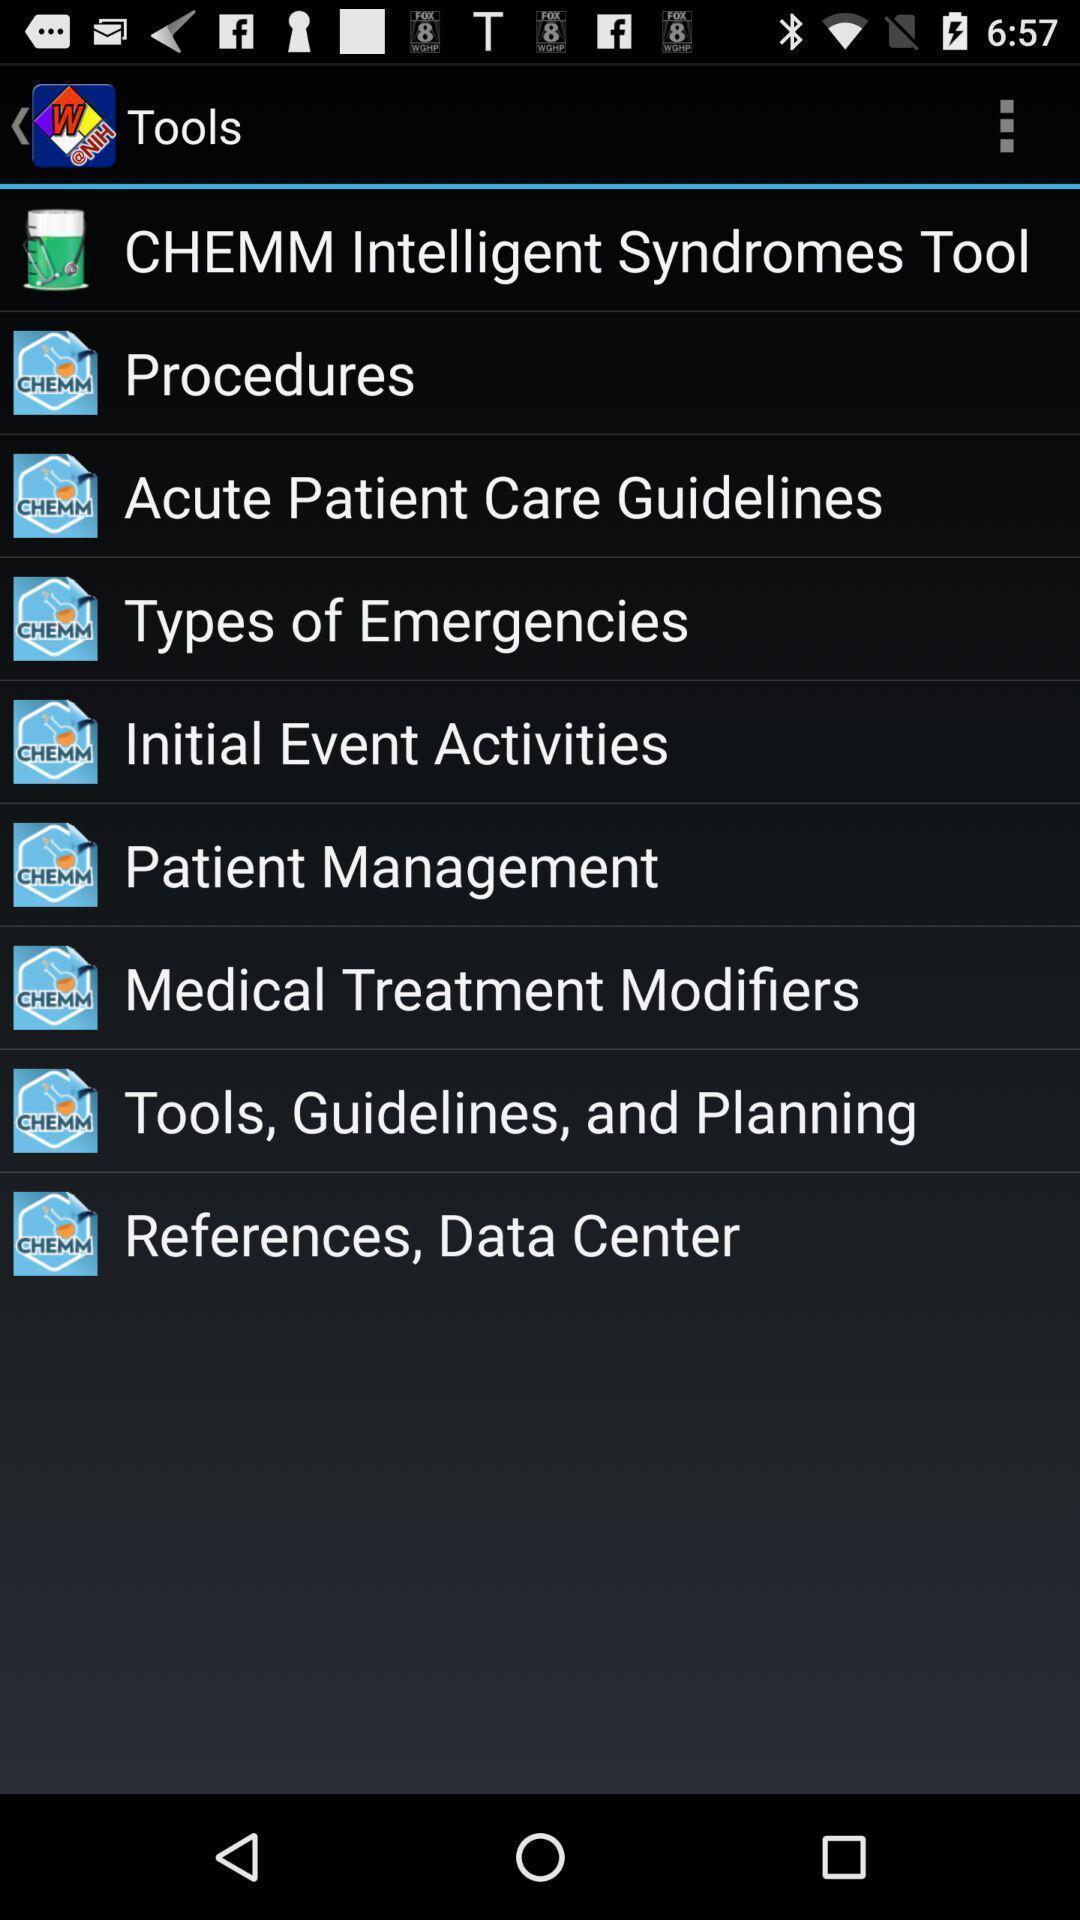Describe the visual elements of this screenshot. Page showing tools list in the medical treatment app. 